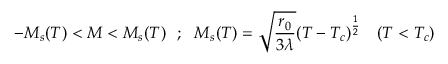<formula> <loc_0><loc_0><loc_500><loc_500>- M _ { s } ( T ) < M < M _ { s } ( T ) ; M _ { s } ( T ) = \sqrt { \frac { r _ { 0 } } { 3 \lambda } } ( T - T _ { c } ) ^ { \frac { 1 } { 2 } } ( T < T _ { c } )</formula> 